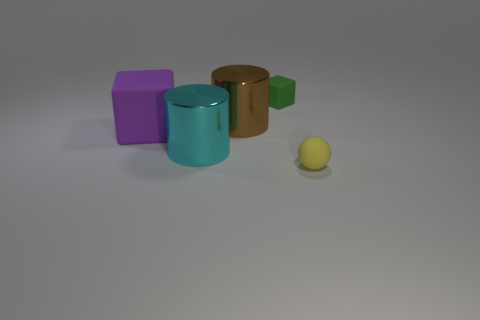Add 3 tiny green objects. How many objects exist? 8 Subtract all purple cubes. How many cubes are left? 1 Subtract all cylinders. How many objects are left? 3 Subtract all blue blocks. Subtract all blue balls. How many blocks are left? 2 Subtract all red cylinders. How many cyan blocks are left? 0 Subtract all brown things. Subtract all rubber blocks. How many objects are left? 2 Add 4 yellow balls. How many yellow balls are left? 5 Add 1 tiny red cylinders. How many tiny red cylinders exist? 1 Subtract 0 red balls. How many objects are left? 5 